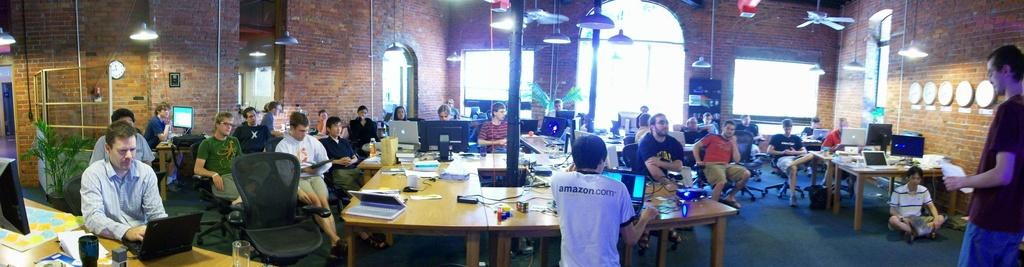What type of structure is visible in the image? There is a brick wall in the image. What can be seen illuminating the area in the image? There is a light in the image. What device is present for air circulation in the image? There is a fan in the image. How are the people in the image seated? There are people sitting on chairs in the image. What type of furniture is present for placing items in the image? There are tables in the image. What items are on the table with the wired, laptop, mouse, cup, and papers? On the same table, there is a wired, laptop, mouse, cup, and papers. Can you see a glass of water on the table with the wired, laptop, mouse, cup, and papers? There is no glass of water mentioned in the provided facts, so we cannot confirm its presence in the image. Is there a toad sitting on the brick wall in the image? There is no mention of a toad in the provided facts, so we cannot confirm its presence in the image. 